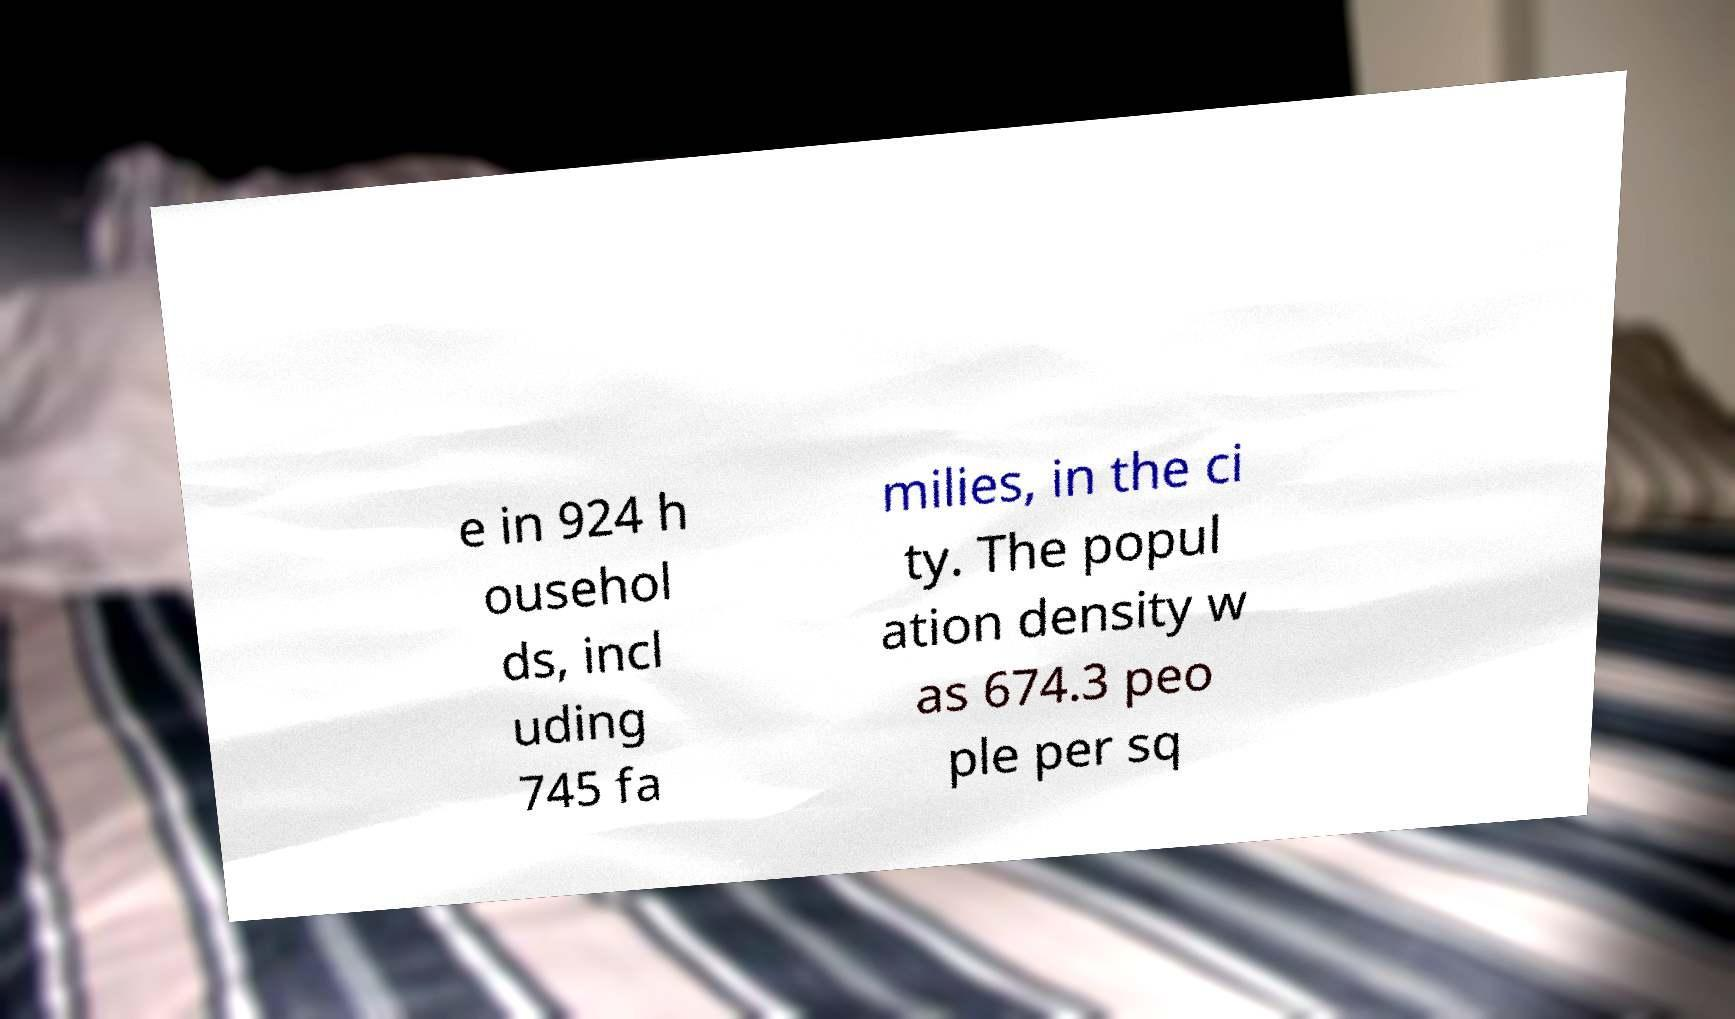What messages or text are displayed in this image? I need them in a readable, typed format. e in 924 h ousehol ds, incl uding 745 fa milies, in the ci ty. The popul ation density w as 674.3 peo ple per sq 